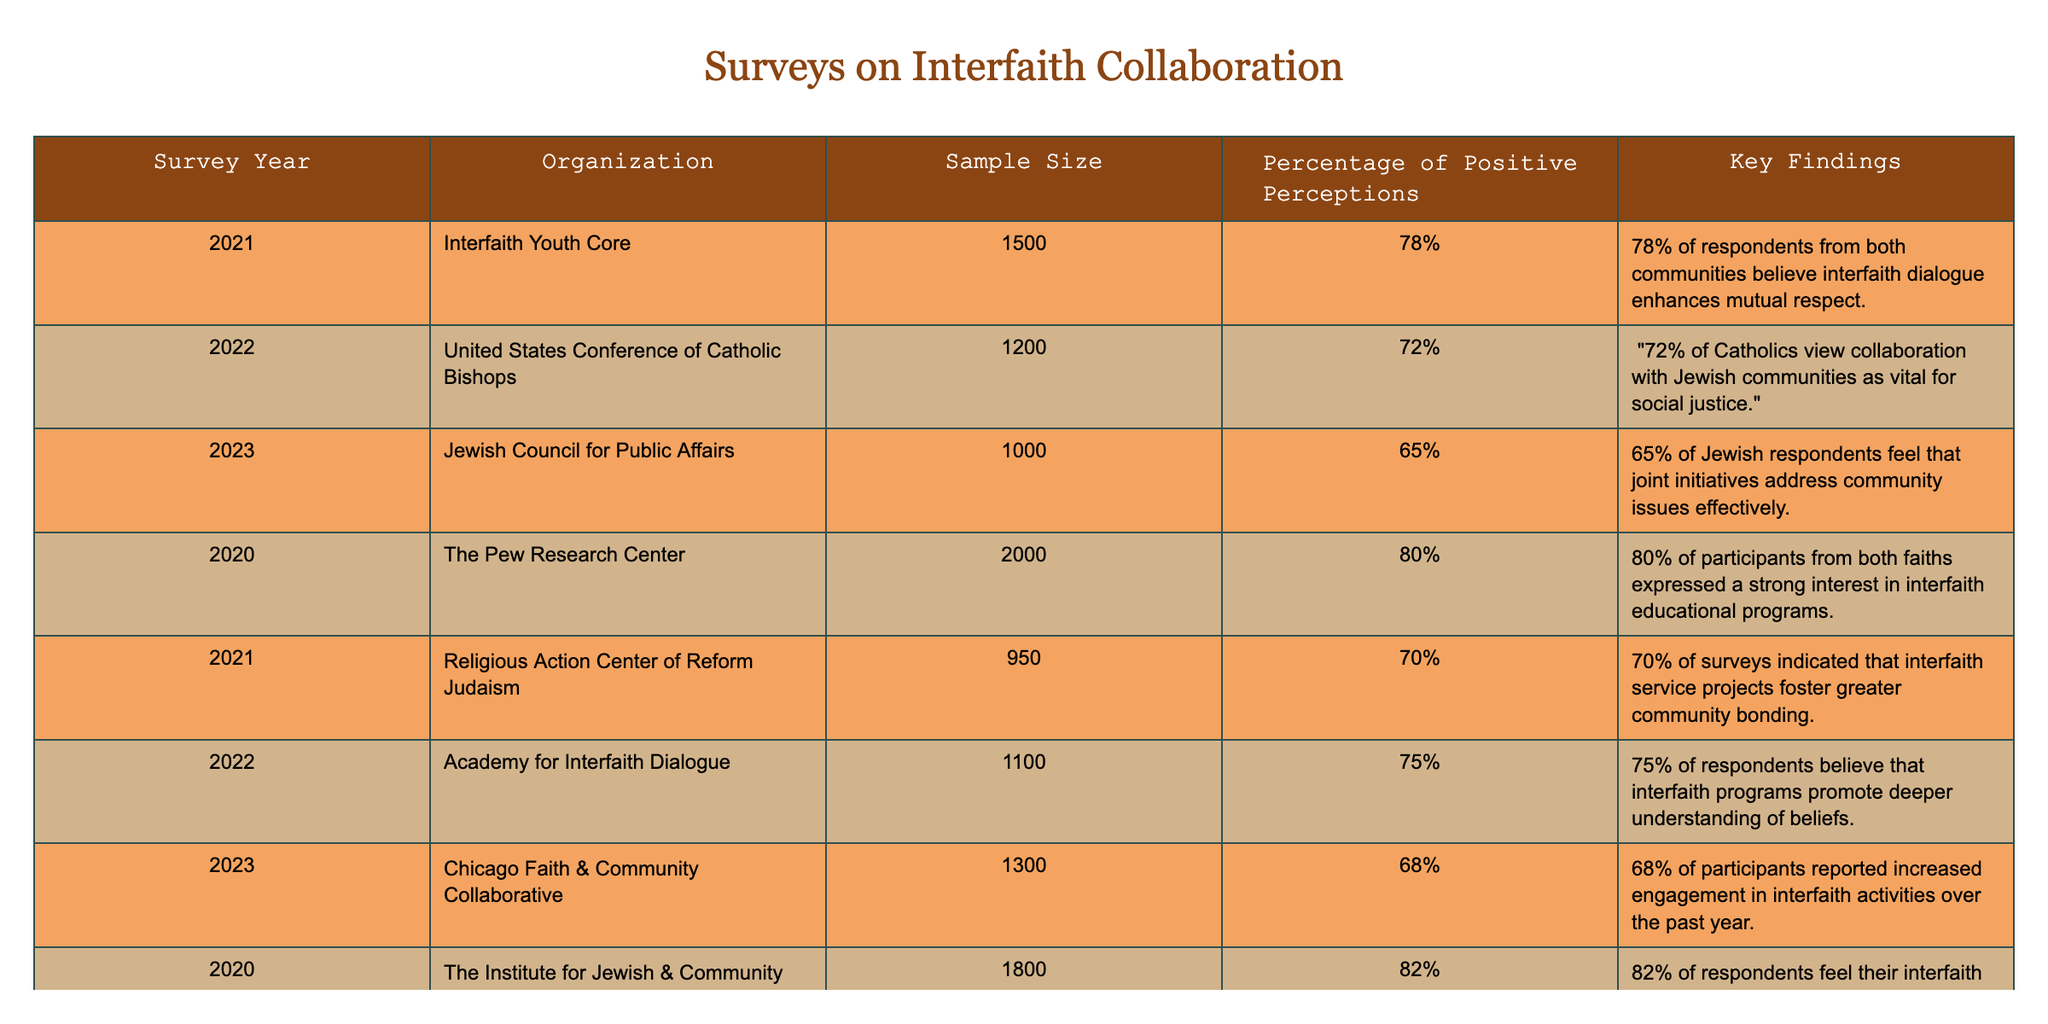What was the sample size of the survey conducted by the United States Conference of Catholic Bishops in 2022? The table lists the sample size for each survey, and for the 2022 survey by the United States Conference of Catholic Bishops, the sample size is indicated as 1200.
Answer: 1200 Which organization had the highest percentage of positive perceptions regarding interfaith collaboration? By examining the "Percentage of Positive Perceptions" column, The Institute for Jewish & Community Research in 2020 shows the highest percentage at 82%.
Answer: 82% What percentage of respondents from the Interfaith Youth Core in 2021 believe that interfaith dialogue enhances mutual respect? The table specifies that 78% of respondents from both communities in the Interfaith Youth Core survey believe interfaith dialogue enhances mutual respect.
Answer: 78% Is it true that more than 70% of Jewish respondents feel that joint initiatives effectively address community issues? Looking at the "Percentage of Positive Perceptions," the Jewish Council for Public Affairs in 2023 shows only 65%, which is below 70%. Therefore, the statement is false.
Answer: False What is the average percentage of positive perceptions from the surveys conducted in 2021? The percentage from Interfaith Youth Core (78%), and Religious Action Center of Reform Judaism (70%) needs to be averaged. The total is 148% for the two surveys, so the average is 148/2 = 74%.
Answer: 74% How many organizations reported a percentage of positive perceptions that was above 70%? Reviewing the percentages listed, four organizations (Pew Research Center, Institute for Jewish & Community Research, Interfaith Youth Core, and Academy for Interfaith Dialogue) reported percentages of 72% or higher.
Answer: 4 What decrease in positive perceptions can be observed from the 2020 Pew Research Center survey to the 2023 Jewish Council for Public Affairs survey? The Pew Research Center had a positive perception percentage of 80% in 2020, while the Jewish Council for Public Affairs saw this drop to 65% in 2023. The difference is 80 - 65 = 15%.
Answer: 15% Which survey year has the lowest percentage of positive perceptions and what is that percentage? The survey from the Jewish Council for Public Affairs in 2023 has the lowest percentage at 65% among all the listed surveys.
Answer: 65% Did the Academy for Interfaith Dialogue have a higher percentage of positive perceptions than the Chicago Faith & Community Collaborative in 2023? The table shows the Academy for Interfaith Dialogue had 75% while the Chicago Faith & Community Collaborative had 68%. Therefore, the Academy for Interfaith Dialogue had a higher percentage.
Answer: Yes 